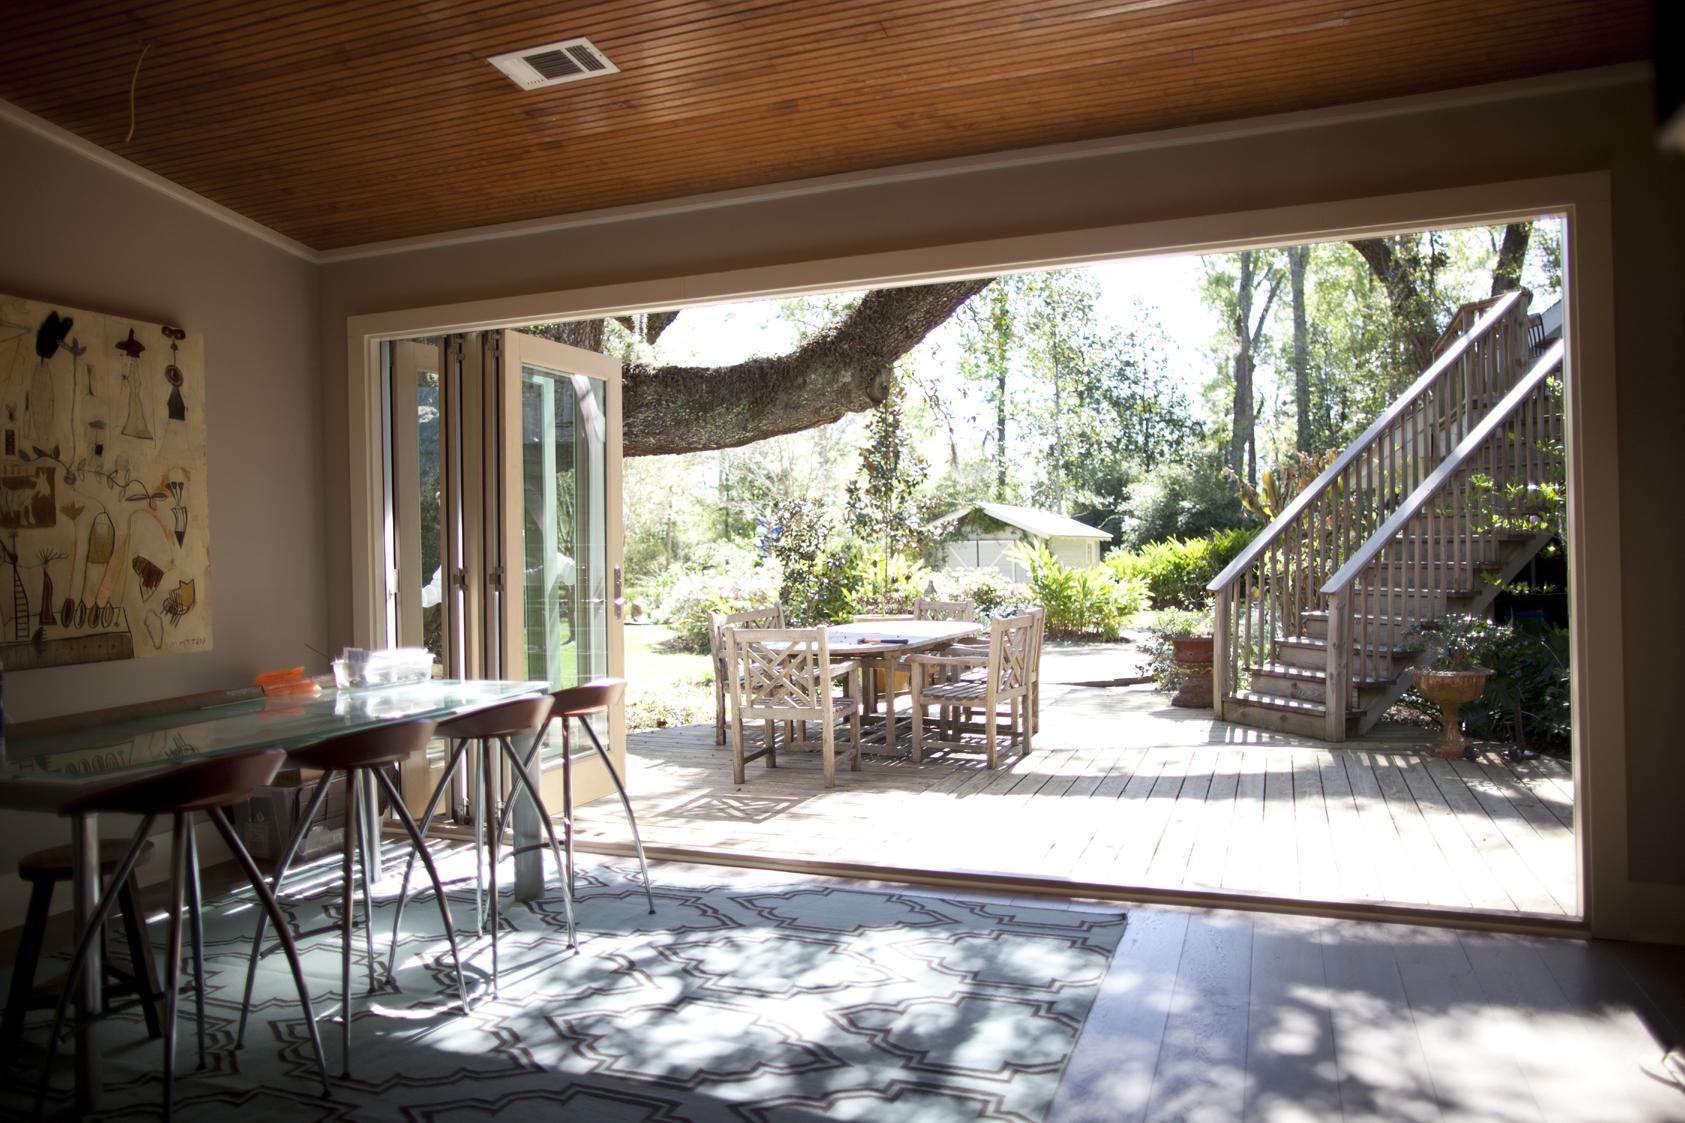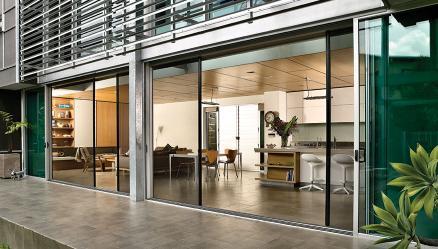The first image is the image on the left, the second image is the image on the right. For the images displayed, is the sentence "In at least image there are six chairs surrounding a square table on the patio." factually correct? Answer yes or no. Yes. 